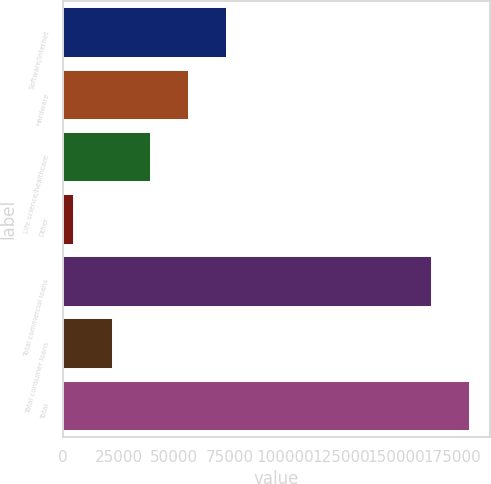Convert chart to OTSL. <chart><loc_0><loc_0><loc_500><loc_500><bar_chart><fcel>Software/internet<fcel>Hardware<fcel>Life science/healthcare<fcel>Other<fcel>Total commercial loans<fcel>Total consumer loans<fcel>Total<nl><fcel>73337.4<fcel>56136.8<fcel>38936.2<fcel>4535<fcel>165480<fcel>21735.6<fcel>182681<nl></chart> 